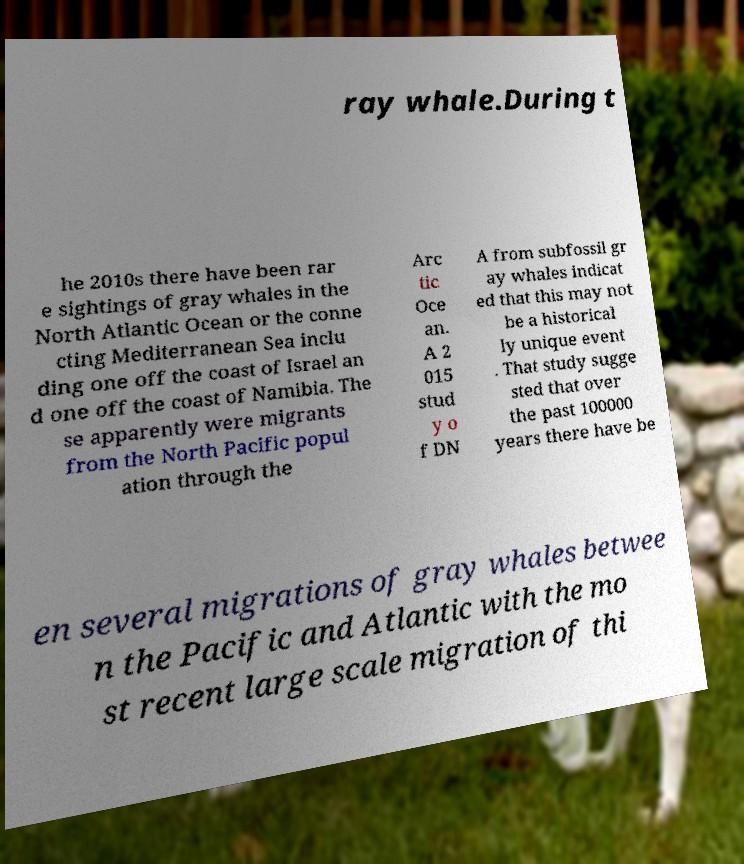Can you read and provide the text displayed in the image?This photo seems to have some interesting text. Can you extract and type it out for me? ray whale.During t he 2010s there have been rar e sightings of gray whales in the North Atlantic Ocean or the conne cting Mediterranean Sea inclu ding one off the coast of Israel an d one off the coast of Namibia. The se apparently were migrants from the North Pacific popul ation through the Arc tic Oce an. A 2 015 stud y o f DN A from subfossil gr ay whales indicat ed that this may not be a historical ly unique event . That study sugge sted that over the past 100000 years there have be en several migrations of gray whales betwee n the Pacific and Atlantic with the mo st recent large scale migration of thi 